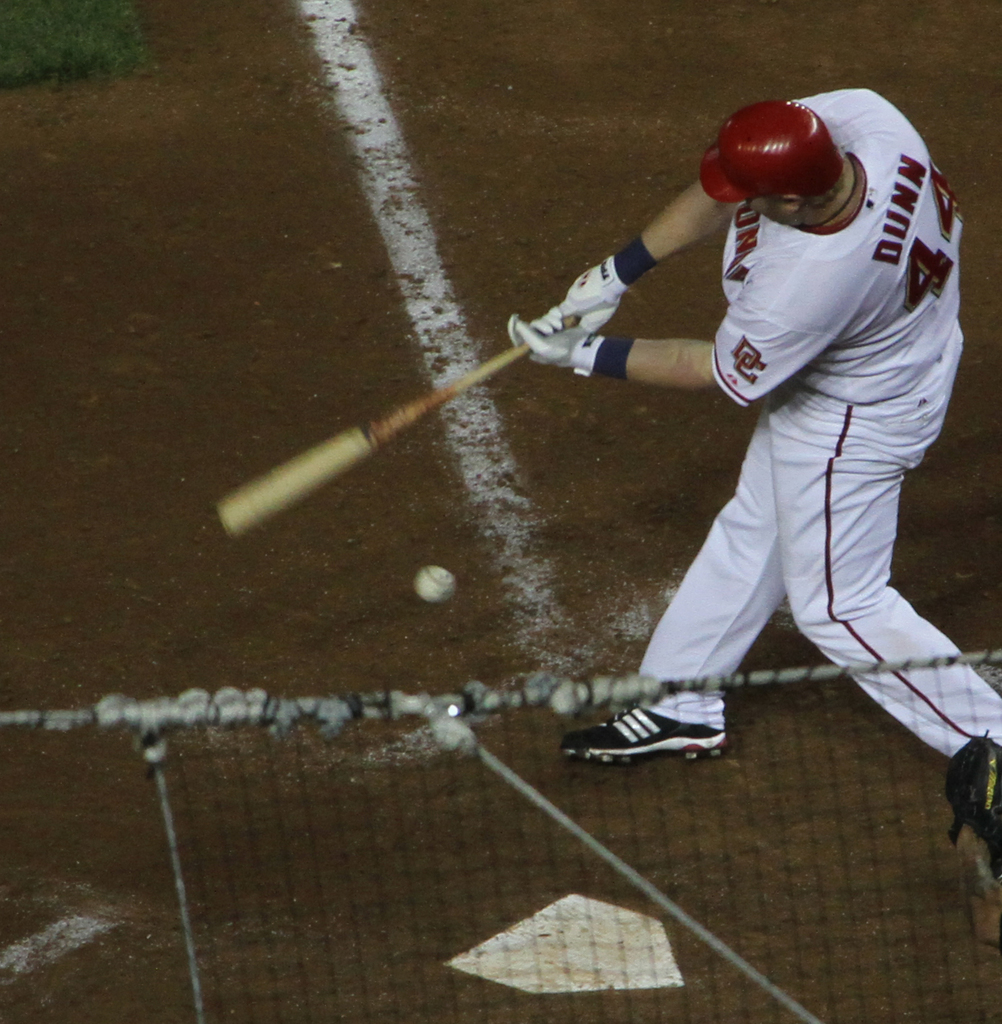How does this image capture the dynamics of the sport? The image captures the critical and high-energy moment as the bat makes contact with the ball, a pivotal part of the game that determines the player's success in his at-bat. 